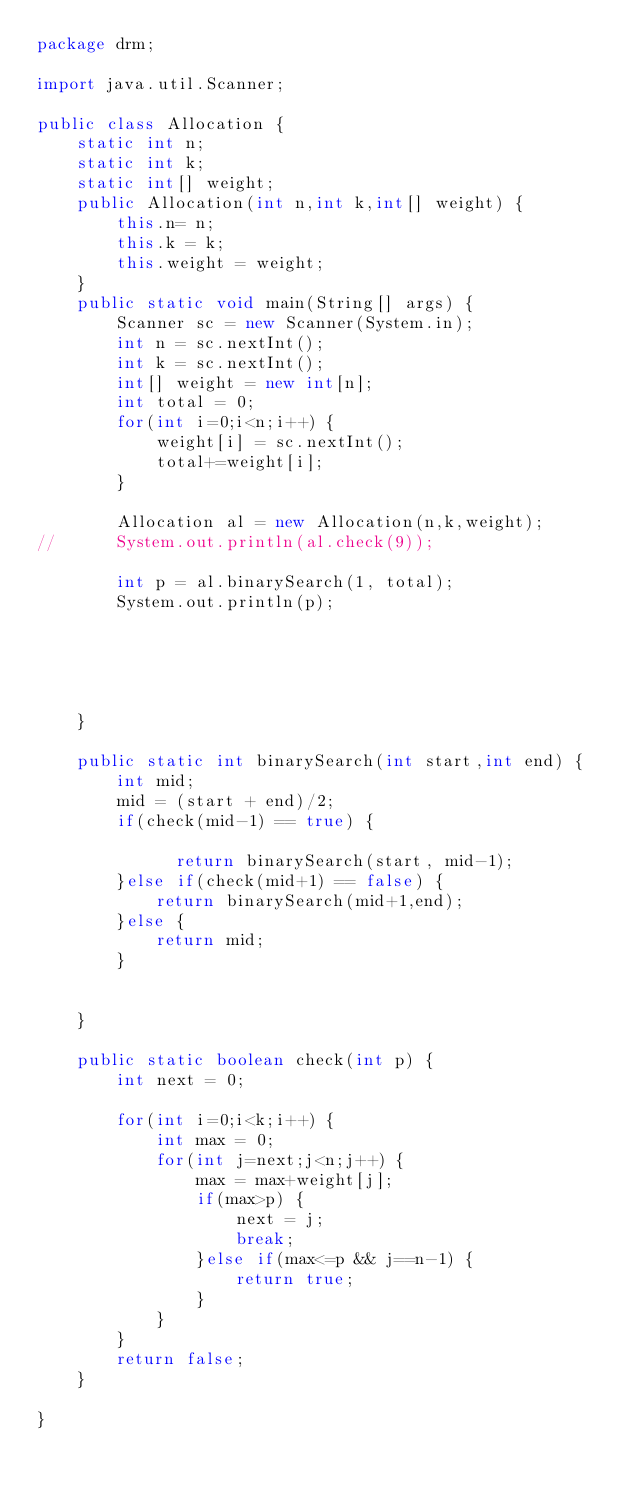<code> <loc_0><loc_0><loc_500><loc_500><_Java_>package drm;

import java.util.Scanner;

public class Allocation {
	static int n;
	static int k;
	static int[] weight;
	public Allocation(int n,int k,int[] weight) {
		this.n= n;
		this.k = k;
		this.weight = weight;
	}
	public static void main(String[] args) {
		Scanner sc = new Scanner(System.in);
		int n = sc.nextInt();
		int k = sc.nextInt();	
		int[] weight = new int[n];
		int total = 0;
		for(int i=0;i<n;i++) {
			weight[i] = sc.nextInt();
			total+=weight[i];
		}
		
		Allocation al = new Allocation(n,k,weight);
//		System.out.println(al.check(9));
		
		int p = al.binarySearch(1, total);
		System.out.println(p);
		
		
		
		

	}
	
	public static int binarySearch(int start,int end) {
		int mid;
		mid = (start + end)/2;
		if(check(mid-1) == true) {
			
			  return binarySearch(start, mid-1);
		}else if(check(mid+1) == false) {
			return binarySearch(mid+1,end);
		}else {
			return mid;
		}
		
		
	}
	
	public static boolean check(int p) {
		int next = 0;
		
		for(int i=0;i<k;i++) {	
			int max = 0;
			for(int j=next;j<n;j++) {
				max = max+weight[j];
				if(max>p) {
					next = j;
					break;
				}else if(max<=p && j==n-1) {
					return true;
				}
			}
		}
		return false;
	}

}

</code> 